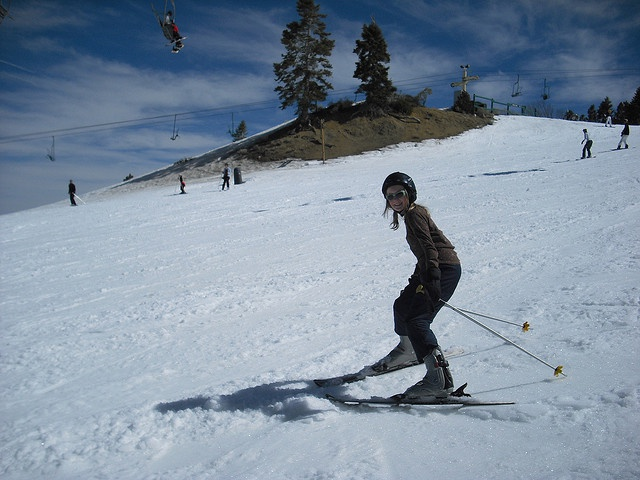Describe the objects in this image and their specific colors. I can see people in black, gray, and darkgray tones, skis in black, gray, and darkgray tones, people in black, gray, and darkgray tones, people in black, gray, darkgray, and blue tones, and people in black, gray, maroon, and darkblue tones in this image. 